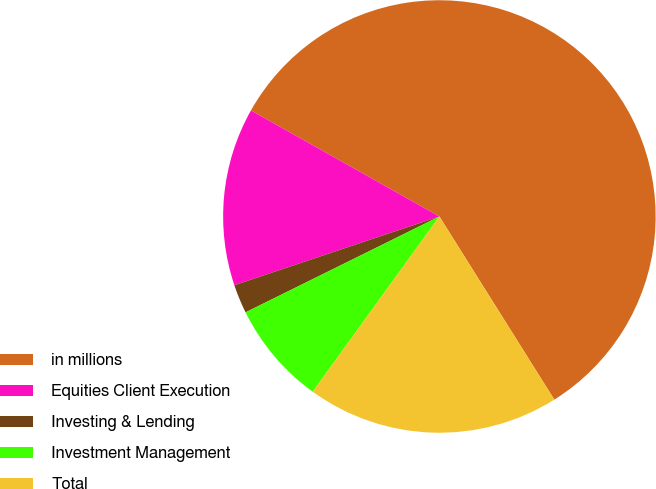Convert chart to OTSL. <chart><loc_0><loc_0><loc_500><loc_500><pie_chart><fcel>in millions<fcel>Equities Client Execution<fcel>Investing & Lending<fcel>Investment Management<fcel>Total<nl><fcel>57.92%<fcel>13.31%<fcel>2.16%<fcel>7.73%<fcel>18.88%<nl></chart> 